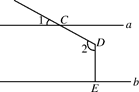How can the concept of vertically opposite angles be explained using this image? The image showcases the concept of vertically opposite angles beautifully through the angles formed at points C and D. Vertically opposite angles occur when two lines intersect, creating two pairs of opposite angles that are equal. Here, angles at points C and D are equal due to them being vertically opposite. This principle helps in establishing angle identities and solving for unknowns in complex geometric configurations. It's a crucial concept in understanding more intricate geometrical relationships. 